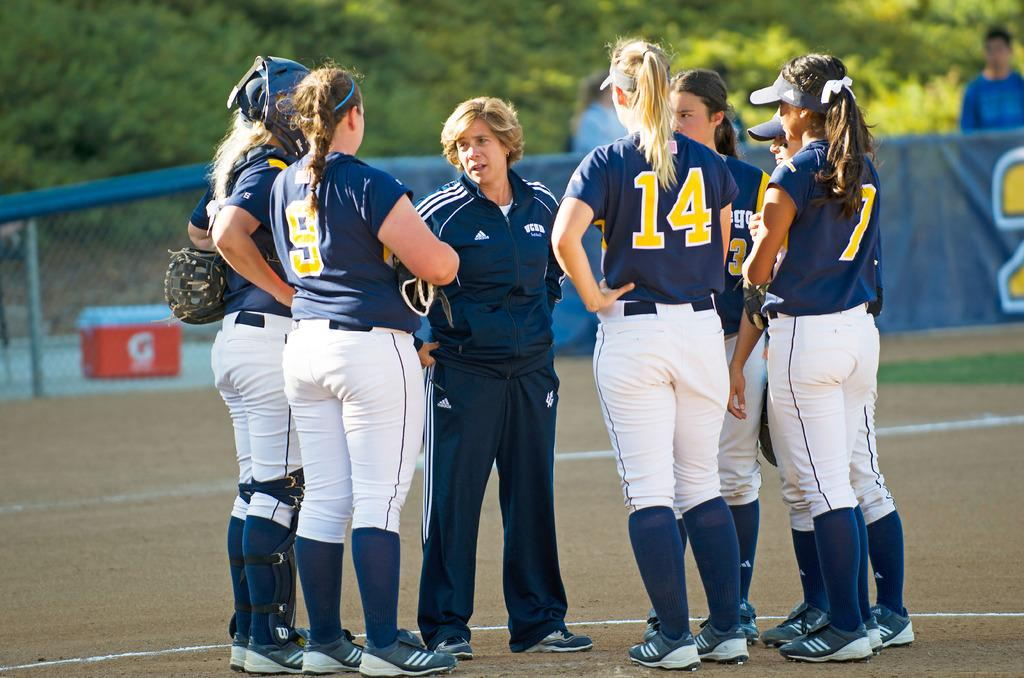<image>
Render a clear and concise summary of the photo. Many female baseball players one with 14 on her shirt are talking to the coach. 